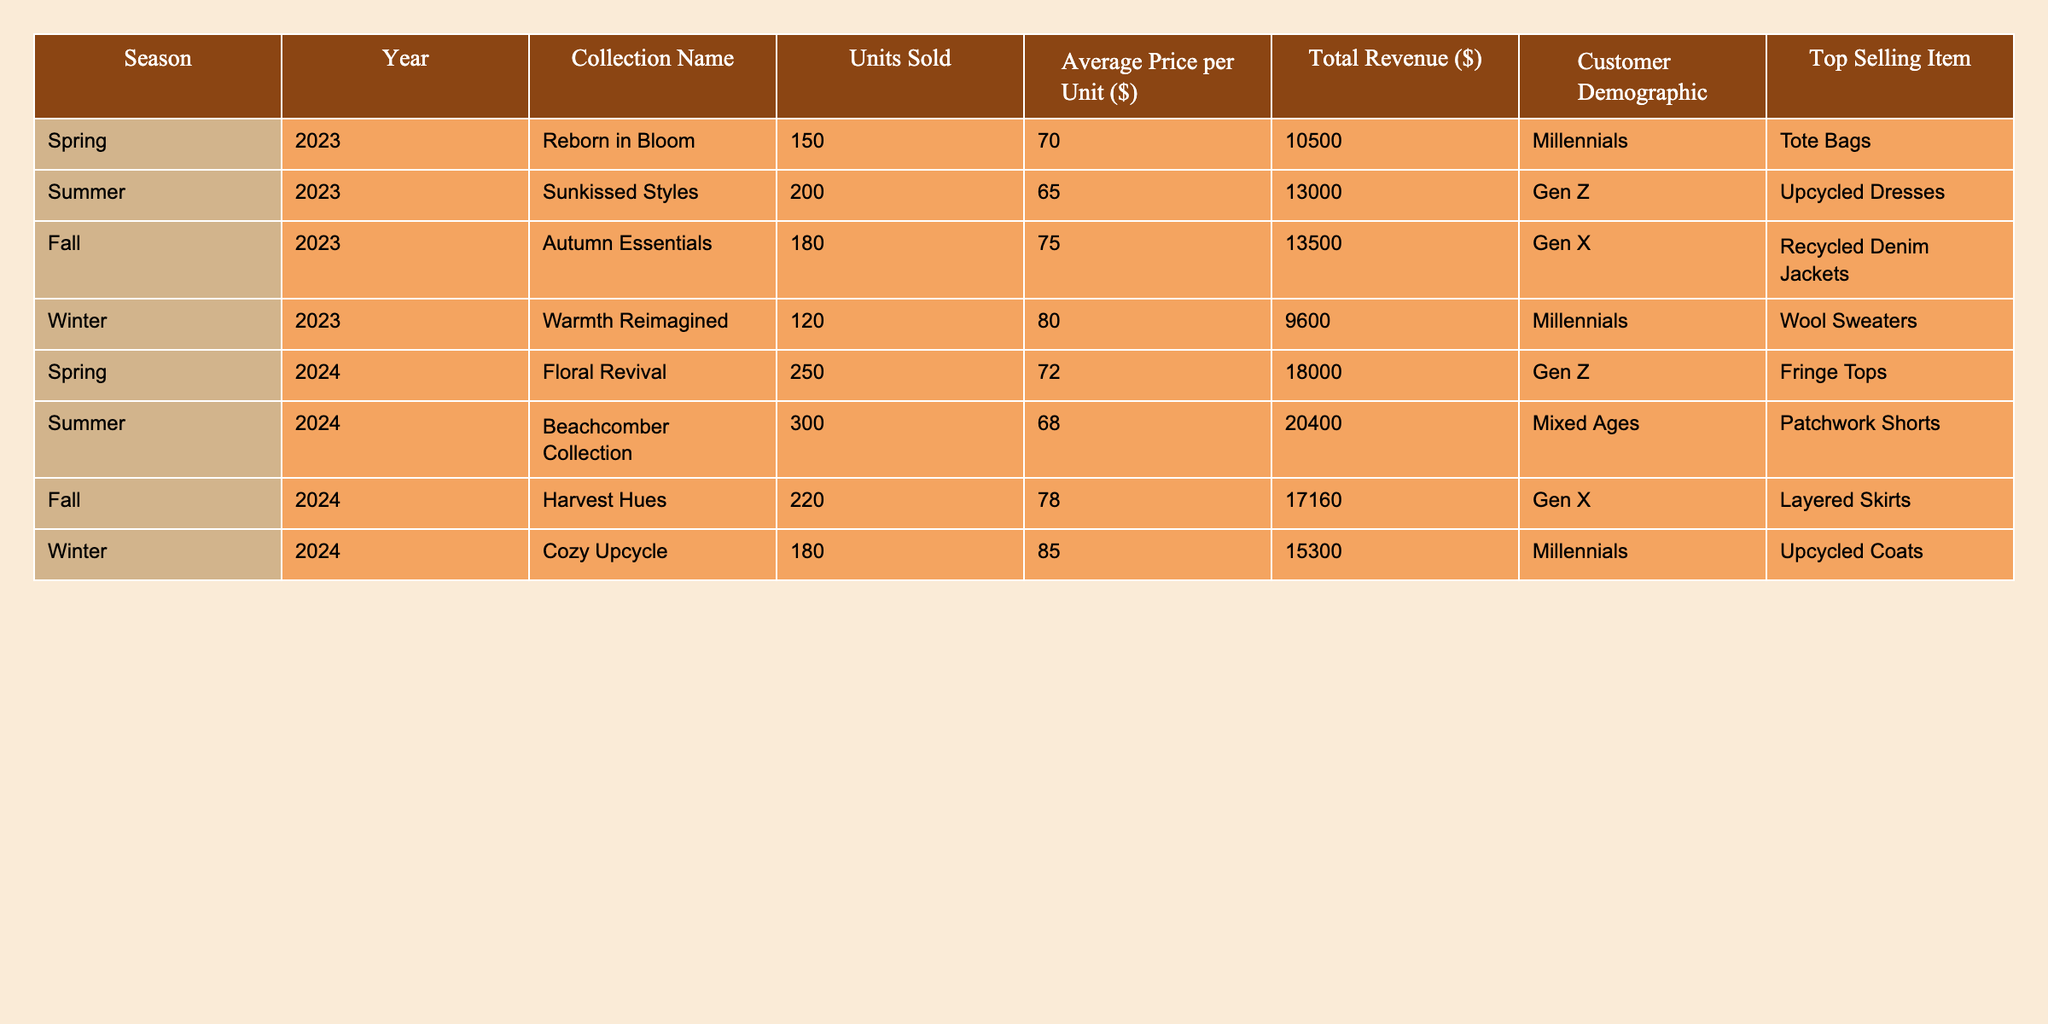What was the total revenue from the Floral Revival collection in Spring 2024? The total revenue for the Floral Revival collection is specified in the table as $18,000.
Answer: $18,000 Which season had the highest units sold overall? The units sold are 150 (Spring 2023), 200 (Summer 2023), 180 (Fall 2023), 120 (Winter 2023), 250 (Spring 2024), 300 (Summer 2024), 220 (Fall 2024), and 180 (Winter 2024). The highest is 300 units from the Summer 2024 collection.
Answer: Summer 2024 What is the average price per unit for the Autumn Essentials collection? The average price per unit for Autumn Essentials is listed as $75 in the table.
Answer: $75 Is the top selling item in Winter 2023 a wool sweater? The top selling item for Winter 2023 is mentioned in the table as Wool Sweaters, making the statement true.
Answer: Yes How much revenue was generated in the Summer of 2023 compared to Spring of 2024? The revenue for Summer 2023 is $13,000 and for Spring 2024, it is $18,000. To compare, $18,000 - $13,000 = $5,000 more revenue in Spring 2024.
Answer: $5,000 What season generated the least amount of total revenue? The total revenues are $10,500 (Spring 2023), $13,000 (Summer 2023), $13,500 (Fall 2023), $9,600 (Winter 2023), $18,000 (Spring 2024), $20,400 (Summer 2024), $17,160 (Fall 2024), and $15,300 (Winter 2024). The least revenue is $9,600 from Winter 2023.
Answer: Winter 2023 Which customer demographic purchased the most items in the Summer 2024 season? The customer demographic listed for the Summer 2024 Beachcomber Collection is Mixed Ages.
Answer: Mixed Ages How many more units were sold from the Beachcomber Collection compared to the Warmth Reimagined collection? The units sold for Beachcomber Collection (Summer 2024) is 300, while for Warmth Reimagined (Winter 2023) it is 120. The difference is 300 - 120 = 180 more units sold.
Answer: 180 Are Millennials the customer demographic for the Autumn Essentials collection? The customer demographic for the Autumn Essentials collection is Gen X, so the statement is false.
Answer: No Which collection had the highest average price per unit? The average prices per unit are $70 (Reborn in Bloom), $65 (Sunkissed Styles), $75 (Autumn Essentials), $80 (Warmth Reimagined), $72 (Floral Revival), $68 (Beachcomber Collection), $78 (Harvest Hues), and $85 (Cozy Upcycle). The highest average price is $85 for the Cozy Upcycle collection.
Answer: Cozy Upcycle 